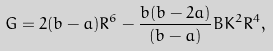<formula> <loc_0><loc_0><loc_500><loc_500>G = 2 ( b - a ) R ^ { 6 } - \frac { b ( b - 2 a ) } { ( b - a ) } B K ^ { 2 } R ^ { 4 } ,</formula> 